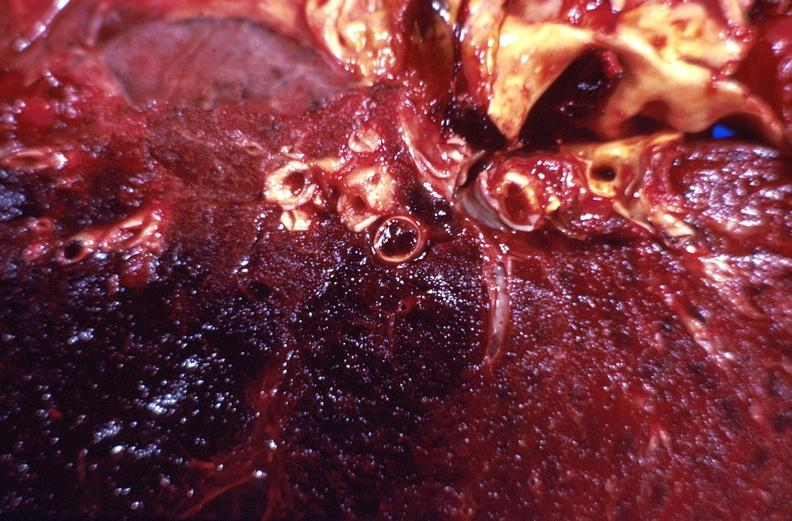does this image show subacute pulmonary thromboembolus with acute infarct?
Answer the question using a single word or phrase. Yes 